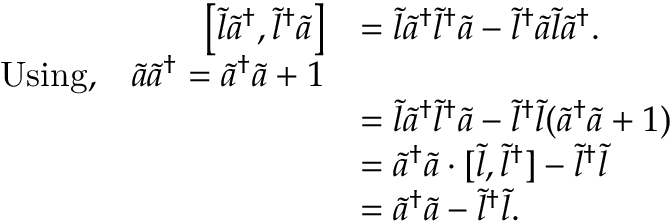<formula> <loc_0><loc_0><loc_500><loc_500>\begin{array} { r l } { \left [ \tilde { l } \tilde { a } ^ { \dagger } , \tilde { l } ^ { \dagger } \tilde { a } \right ] } & { = \tilde { l } \tilde { a } ^ { \dagger } \tilde { l } ^ { \dagger } \tilde { a } - \tilde { l } ^ { \dagger } \tilde { a } \tilde { l } \tilde { a } ^ { \dagger } . } \\ { U \sin g , { \quad } \tilde { a } \tilde { a } ^ { \dagger } = \tilde { a } ^ { \dagger } \tilde { a } + 1 } \\ & { = \tilde { l } \tilde { a } ^ { \dagger } \tilde { l } ^ { \dagger } \tilde { a } - \tilde { l } ^ { \dagger } \tilde { l } ( \tilde { a } ^ { \dagger } \tilde { a } + 1 ) } \\ & { = \tilde { a } ^ { \dagger } \tilde { a } \cdot [ \tilde { l } , \tilde { l } ^ { \dagger } ] - \tilde { l } ^ { \dagger } \tilde { l } } \\ & { = \tilde { a } ^ { \dagger } \tilde { a } - \tilde { l } ^ { \dagger } \tilde { l } . } \end{array}</formula> 